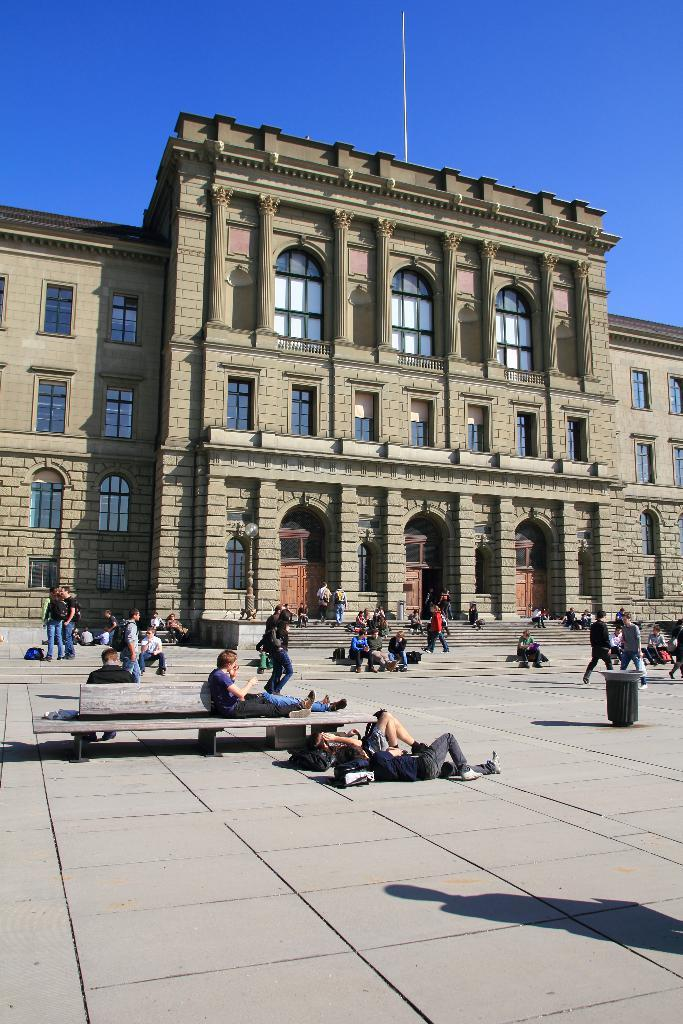What type of structures can be seen in the image? There are buildings in the image. What architectural features are present in the buildings? There are windows in the image. What type of seating is available in the image? There are benches in the image. Who or what is present in the image? There are people in the image. What is a feature that allows access to different levels in the image? There are stairs in the image. What is visible in the background of the image? The sky is visible in the image. What type of ground is visible in the image? There is no specific ground mentioned in the image; it only shows buildings, windows, benches, people, stairs, and the sky. What shape is the square in the image? There is no square present in the image. 